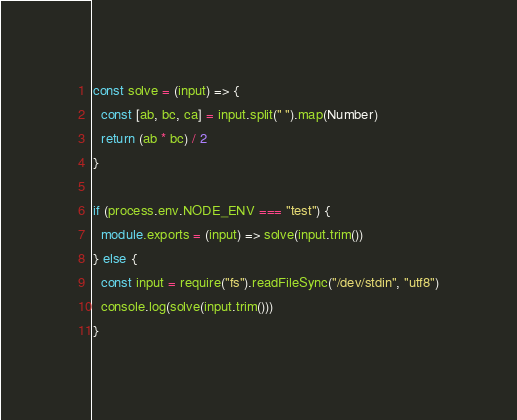Convert code to text. <code><loc_0><loc_0><loc_500><loc_500><_TypeScript_>const solve = (input) => {
  const [ab, bc, ca] = input.split(" ").map(Number)
  return (ab * bc) / 2
}

if (process.env.NODE_ENV === "test") {
  module.exports = (input) => solve(input.trim())
} else {
  const input = require("fs").readFileSync("/dev/stdin", "utf8")
  console.log(solve(input.trim()))
}
</code> 